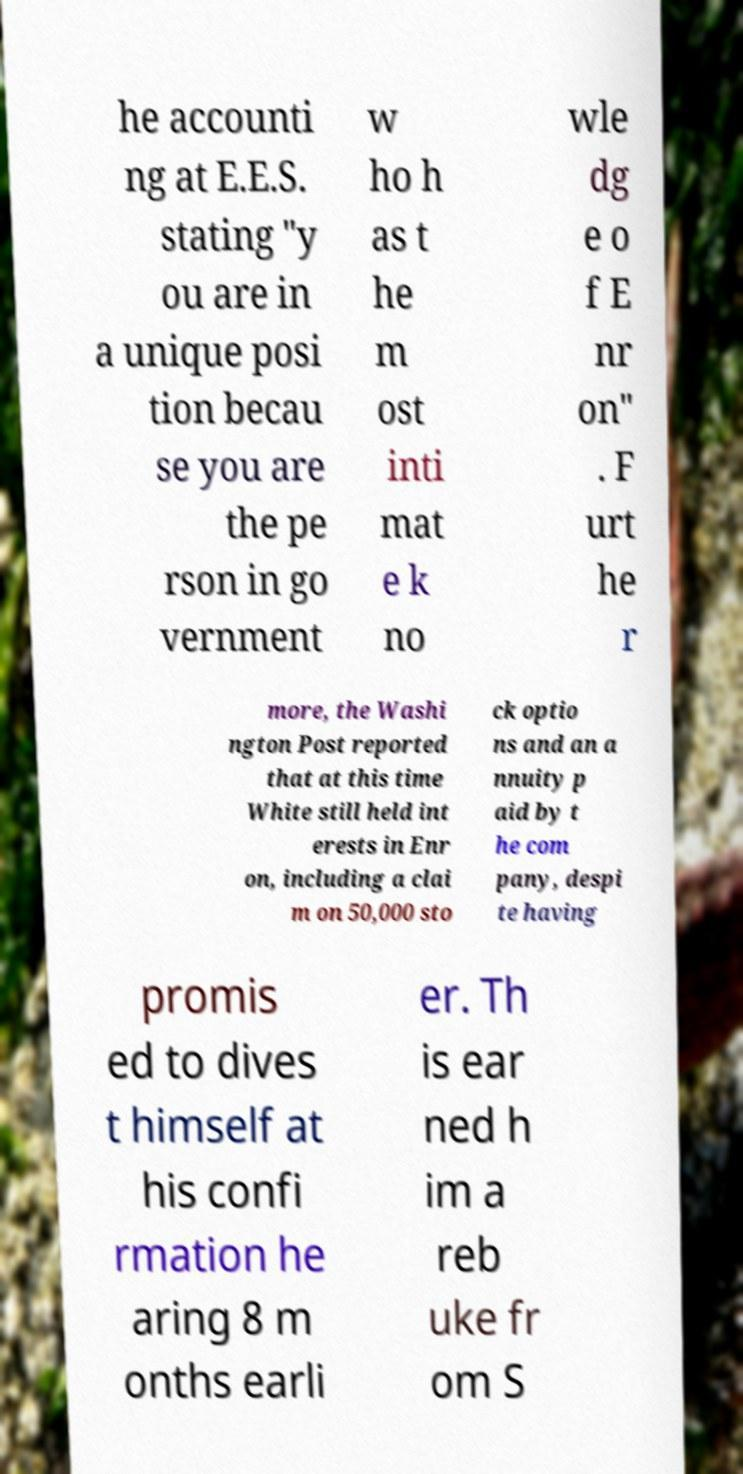Please read and relay the text visible in this image. What does it say? he accounti ng at E.E.S. stating "y ou are in a unique posi tion becau se you are the pe rson in go vernment w ho h as t he m ost inti mat e k no wle dg e o f E nr on" . F urt he r more, the Washi ngton Post reported that at this time White still held int erests in Enr on, including a clai m on 50,000 sto ck optio ns and an a nnuity p aid by t he com pany, despi te having promis ed to dives t himself at his confi rmation he aring 8 m onths earli er. Th is ear ned h im a reb uke fr om S 